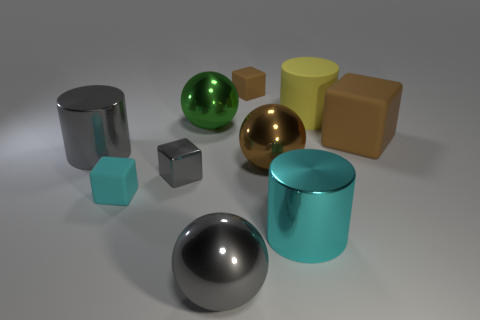Is the size of the cyan rubber object the same as the gray block?
Offer a very short reply. Yes. Is the number of gray spheres that are left of the large green ball the same as the number of gray metallic objects on the left side of the big gray metal ball?
Your answer should be very brief. No. Is there a gray shiny cylinder?
Ensure brevity in your answer.  Yes. There is a brown thing that is the same shape as the green metallic thing; what is its size?
Ensure brevity in your answer.  Large. What size is the gray metal thing in front of the cyan matte cube?
Your answer should be very brief. Large. Are there more big green balls on the left side of the yellow rubber cylinder than small red rubber spheres?
Your answer should be compact. Yes. What is the shape of the small cyan object?
Your response must be concise. Cube. Do the large shiny cylinder that is in front of the small cyan thing and the small matte thing that is in front of the large gray metallic cylinder have the same color?
Your response must be concise. Yes. Is the shape of the small brown rubber thing the same as the yellow thing?
Offer a very short reply. No. Is the cylinder in front of the gray shiny cylinder made of the same material as the small brown block?
Provide a succinct answer. No. 